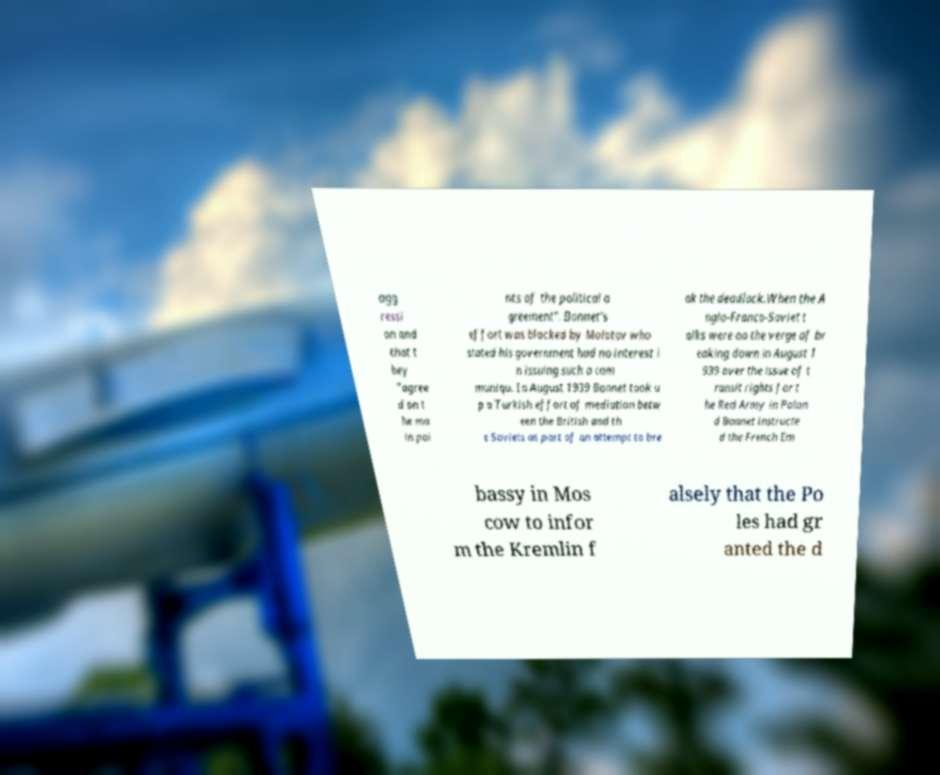Can you read and provide the text displayed in the image?This photo seems to have some interesting text. Can you extract and type it out for me? agg ressi on and that t hey "agree d on t he ma in poi nts of the political a greement". Bonnet's effort was blocked by Molotov who stated his government had no interest i n issuing such a com muniqu. In August 1939 Bonnet took u p a Turkish effort of mediation betw een the British and th e Soviets as part of an attempt to bre ak the deadlock.When the A nglo-Franco-Soviet t alks were on the verge of br eaking down in August 1 939 over the issue of t ransit rights for t he Red Army in Polan d Bonnet instructe d the French Em bassy in Mos cow to infor m the Kremlin f alsely that the Po les had gr anted the d 